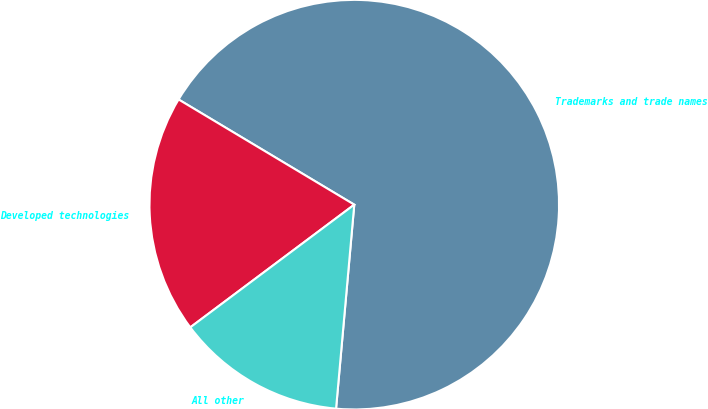Convert chart to OTSL. <chart><loc_0><loc_0><loc_500><loc_500><pie_chart><fcel>Trademarks and trade names<fcel>Developed technologies<fcel>All other<nl><fcel>67.83%<fcel>18.81%<fcel>13.36%<nl></chart> 